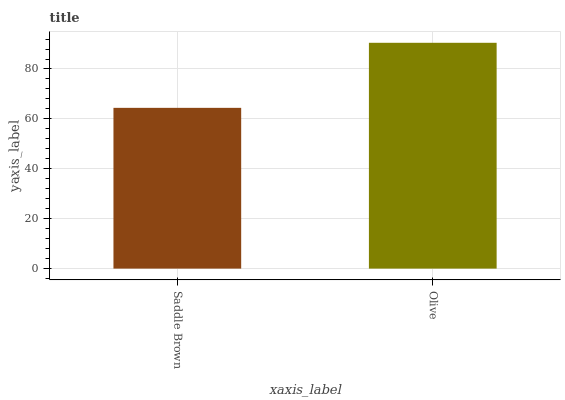Is Saddle Brown the minimum?
Answer yes or no. Yes. Is Olive the maximum?
Answer yes or no. Yes. Is Olive the minimum?
Answer yes or no. No. Is Olive greater than Saddle Brown?
Answer yes or no. Yes. Is Saddle Brown less than Olive?
Answer yes or no. Yes. Is Saddle Brown greater than Olive?
Answer yes or no. No. Is Olive less than Saddle Brown?
Answer yes or no. No. Is Olive the high median?
Answer yes or no. Yes. Is Saddle Brown the low median?
Answer yes or no. Yes. Is Saddle Brown the high median?
Answer yes or no. No. Is Olive the low median?
Answer yes or no. No. 